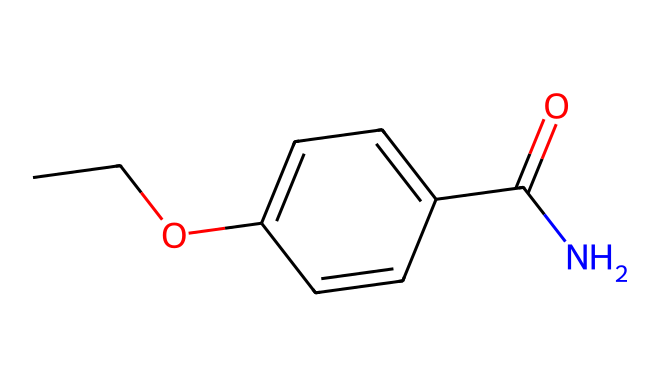What is the chemical name of the compound represented by the SMILES? The SMILES representation indicates the compound has an ester functional group (due to the C(=O)O linkage) and an amine group (due to the presence of the nitrogen atom). This specific structure corresponds to benzocaine, a well-known local anesthetic.
Answer: benzocaine How many carbon atoms are in the structure? By examining the SMILES notation, we see "CC" indicates 2 carbons from the ethyl group, and there are additional carbon atoms in the aromatic ring (c1ccc(cc1), which contains 6 carbon atoms). Adding these gives a total of 8 carbon atoms.
Answer: 8 What type of functional group is present in benzocaine? The structure includes a carbonyl group (C=O) linked to an oxygen atom in an ester (indicated by C(=O)O) and also an amine group (N), confirming it as an ester with an amide component.
Answer: ester and amide How many nitrogen atoms are in the compound? The SMILES representation has a single occurrence of "N", which shows there is only one nitrogen atom present in the chemical structure.
Answer: 1 What is the hybridization of the carbon atoms in the aromatic ring? In the aromatic ring represented by "c1ccc(cc1)", each carbon atom is bonded to another carbon and a hydrogen atom, resulting in sp2 hybridization due to the planar structure and the presence of delocalized pi electrons in the ring.
Answer: sp2 Which part of the molecule is responsible for its anesthetic properties? The nitrogen atom in the compound allows it to interact with nerve receptors. The amine group (–NH) facilitates binding to sodium channels, inhibiting nerve signal transmission, resulting in the anesthetic effect.
Answer: nitrogen atom 